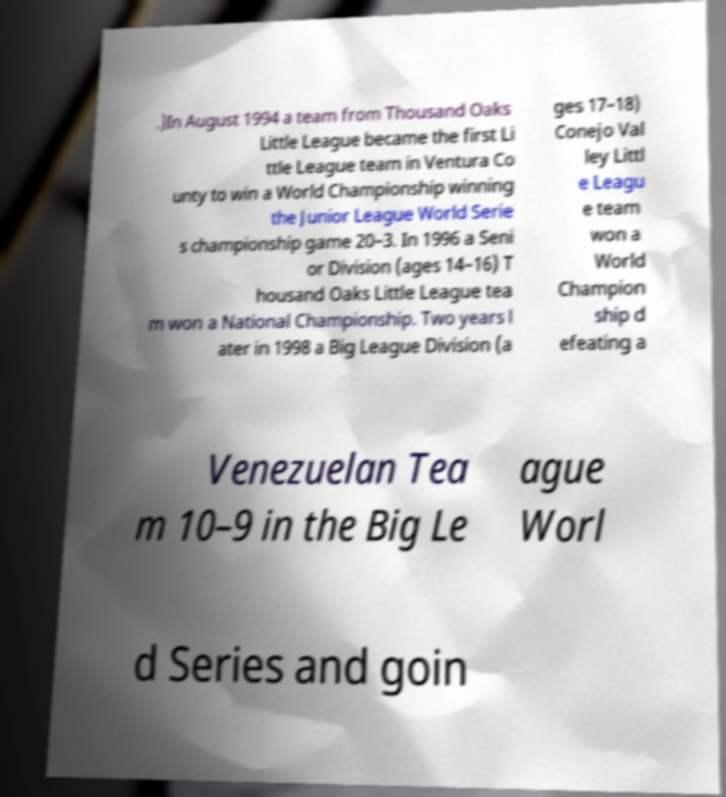Could you extract and type out the text from this image? .)In August 1994 a team from Thousand Oaks Little League became the first Li ttle League team in Ventura Co unty to win a World Championship winning the Junior League World Serie s championship game 20–3. In 1996 a Seni or Division (ages 14–16) T housand Oaks Little League tea m won a National Championship. Two years l ater in 1998 a Big League Division (a ges 17–18) Conejo Val ley Littl e Leagu e team won a World Champion ship d efeating a Venezuelan Tea m 10–9 in the Big Le ague Worl d Series and goin 